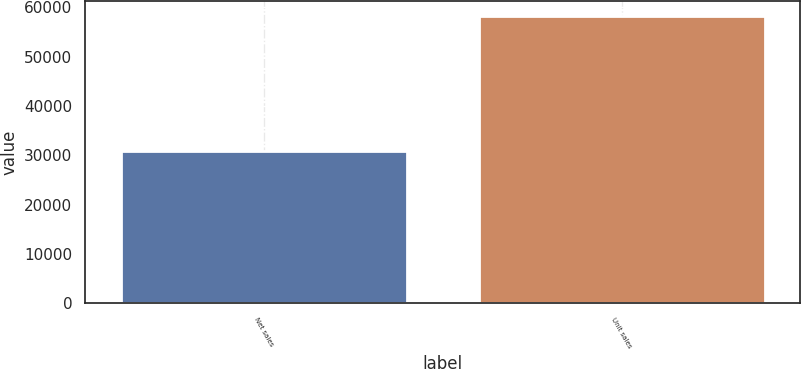Convert chart. <chart><loc_0><loc_0><loc_500><loc_500><bar_chart><fcel>Net sales<fcel>Unit sales<nl><fcel>30945<fcel>58310<nl></chart> 